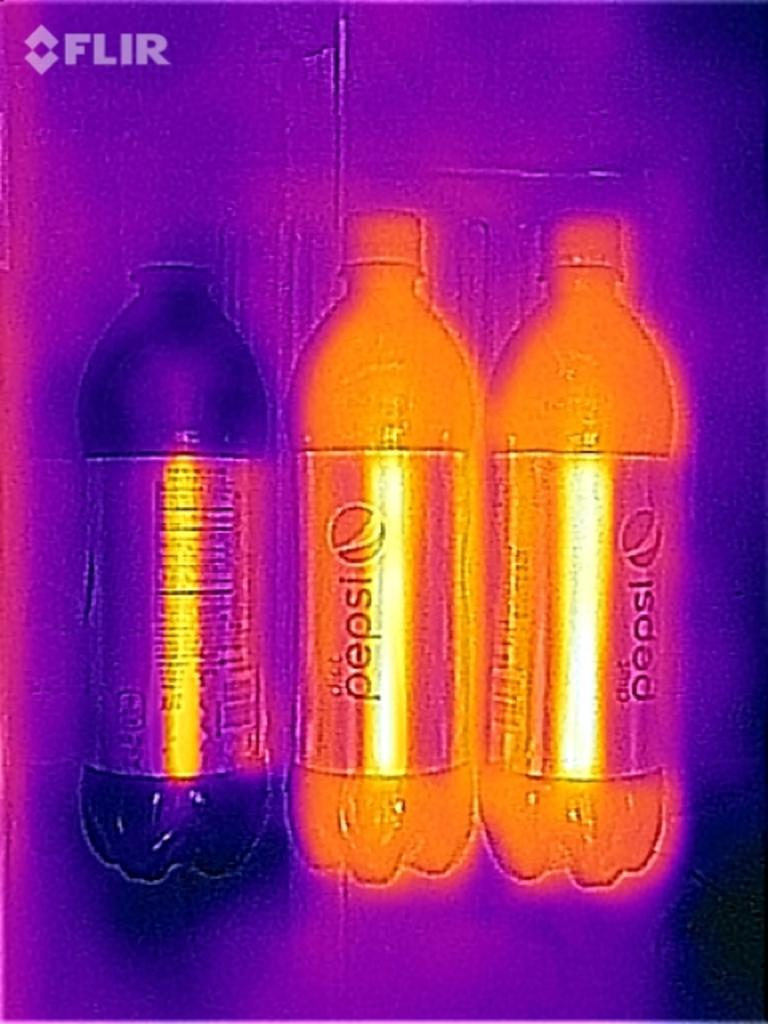Provide a one-sentence caption for the provided image. Three Pepsi bottles are next to each other with unusual orange and pink lighting effects. 